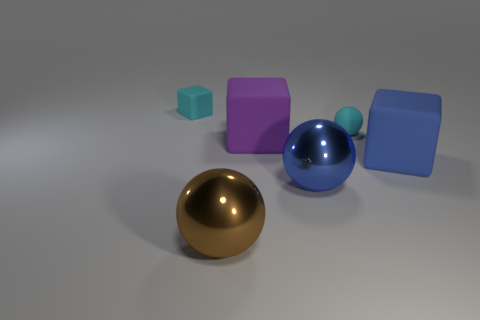What is the material of the tiny cyan object that is the same shape as the large blue rubber thing?
Keep it short and to the point. Rubber. The large brown thing is what shape?
Your answer should be very brief. Sphere. There is a cyan matte object that is on the right side of the block behind the tiny sphere; what is its size?
Your answer should be very brief. Small. What number of objects are large yellow metallic cylinders or big purple matte cubes?
Your response must be concise. 1. Do the big purple matte object and the large blue rubber object have the same shape?
Your answer should be compact. Yes. Are there any large yellow balls made of the same material as the big blue sphere?
Make the answer very short. No. There is a large metallic thing on the left side of the big purple matte thing; is there a big brown metallic object left of it?
Ensure brevity in your answer.  No. There is a cyan object that is to the right of the purple cube; is its size the same as the cyan block?
Provide a short and direct response. Yes. What size is the blue shiny ball?
Make the answer very short. Large. Is there a big sphere of the same color as the small matte ball?
Provide a short and direct response. No. 